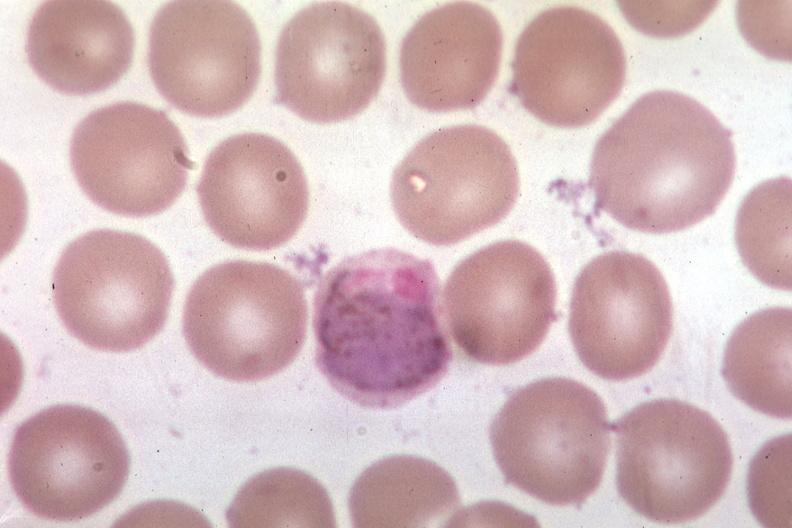what is present?
Answer the question using a single word or phrase. Malaria plasmodium vivax 